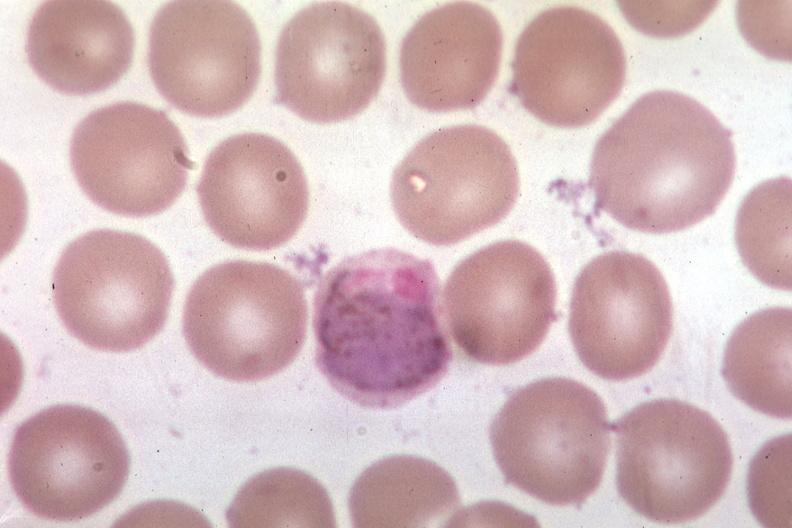what is present?
Answer the question using a single word or phrase. Malaria plasmodium vivax 